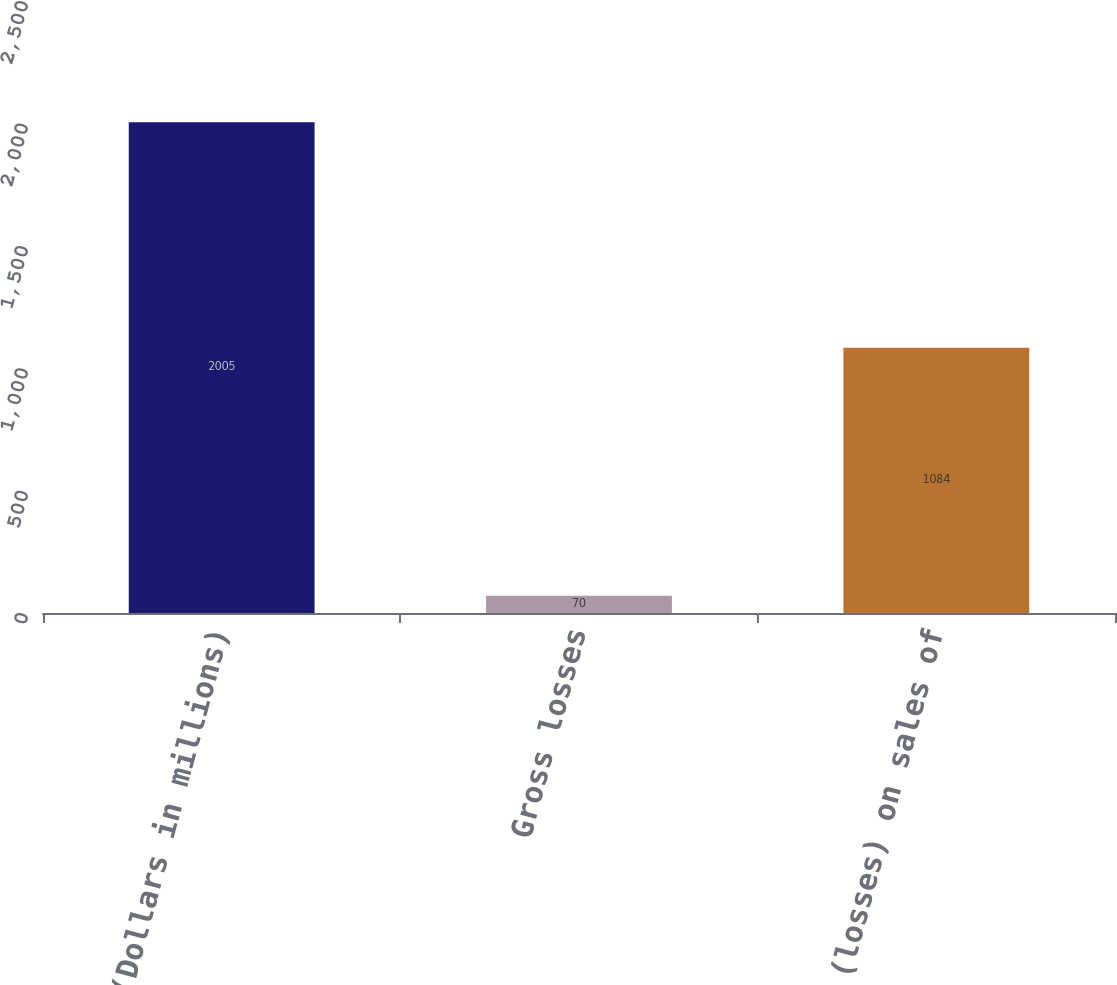<chart> <loc_0><loc_0><loc_500><loc_500><bar_chart><fcel>(Dollars in millions)<fcel>Gross losses<fcel>Net gains (losses) on sales of<nl><fcel>2005<fcel>70<fcel>1084<nl></chart> 